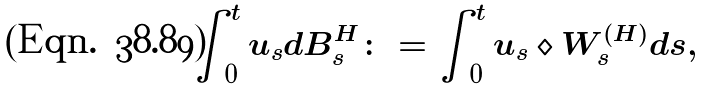Convert formula to latex. <formula><loc_0><loc_0><loc_500><loc_500>\int _ { 0 } ^ { t } u _ { s } d B ^ { H } _ { s } \colon = \int _ { 0 } ^ { t } u _ { s } \diamond W ^ { ( H ) } _ { s } d s ,</formula> 